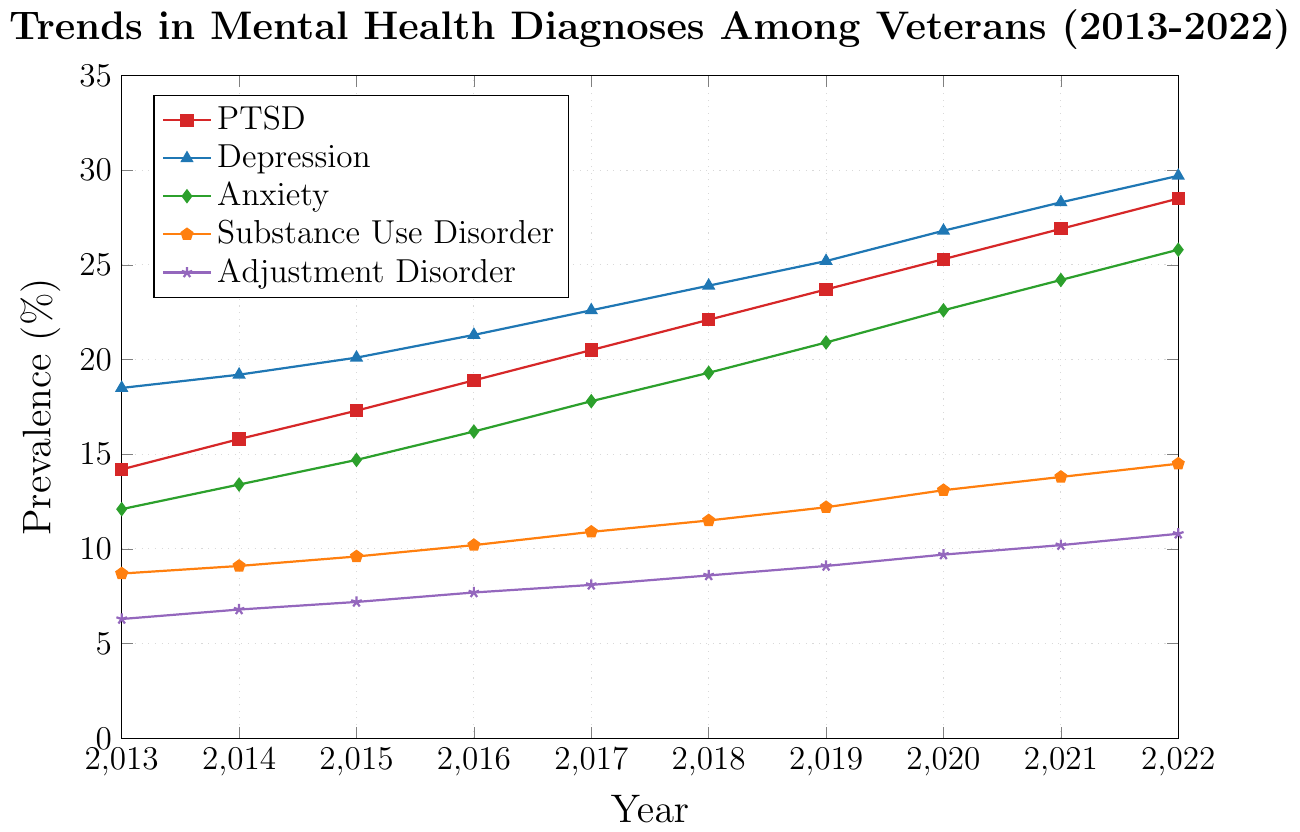What mental health disorder showed the highest prevalence rate in 2022? To determine the highest prevalence rate in 2022, we look at each mental health disorder's value for that year. The values are PTSD (28.5), Depression (29.7), Anxiety (25.8), Substance Use Disorder (14.5), Adjustment Disorder (10.8). Depression has the highest rate.
Answer: Depression Compare the rate of PTSD prevalence in 2013 and 2022. By what percentage did it increase? To calculate the percentage increase, take the value for 2022 (28.5) minus the value for 2013 (14.2), then divide by the 2013 value and multiply by 100: ((28.5 - 14.2) / 14.2) * 100. This results in about 100.7%.
Answer: 100.7% Which disorder showed the smallest increase in prevalence from 2013 to 2022? Examine the increase for each disorder by calculating the difference between their 2022 and 2013 values: PTSD (28.5 - 14.2 = 14.3), Depression (29.7 - 18.5 = 11.2), Anxiety (25.8 - 12.1 = 13.7), Substance Use Disorder (14.5 - 8.7 = 5.8), Adjustment Disorder (10.8 - 6.3 = 4.5). Adjustment Disorder had the smallest increase.
Answer: Adjustment Disorder How did the rate of Anxiety prevalence in 2020 compare to the rate of PTSD prevalence in 2016? To compare the values, look at Anxiety in 2020 (22.6) and PTSD in 2016 (18.9). Anxiety in 2020 was higher than PTSD in 2016.
Answer: Anxiety prevalence in 2020 was higher What was the average prevalence rate of PTSD over the decade shown? Calculate the average by summing up the prevalence rates over the years for PTSD and dividing by the number of years: (14.2 + 15.8 + 17.3 + 18.9 + 20.5 + 22.1 + 23.7 + 25.3 + 26.9 + 28.5) / 10 = 21.32.
Answer: 21.32 Between which consecutive years did Substance Use Disorder show the highest rate of increase? Calculate the year-to-year differences for Substance Use Disorder from 2013 to 2014, 0.4; from 2014 to 2015, 0.5; from 2015 to 2016, 0.6; from 2016 to 2017, 0.7; from 2017 to 2018, 0.6; from 2018 to 2019, 0.7; from 2019 to 2020, 0.9; from 2020 to 2021, 0.7; from 2021 to 2022, 0.7. The highest increase occurred between 2019 and 2020 (0.9).
Answer: 2019 and 2020 What's the trend of Adjustment Disorder prevalence from 2013 to 2022? Observe the data points for Adjustment Disorder from 2013 (6.3) to 2022 (10.8). The prevalence increased gradually each year, indicating a consistent upward trend.
Answer: Upward trend Which disorder had the second-highest prevalence in 2017 and what was its rate? Check the values for 2017: PTSD (20.5), Depression (22.6), Anxiety (17.8), Substance Use Disorder (10.9), and Adjustment Disorder (8.1). The second-highest in 2017 is PTSD with a rate of 20.5%.
Answer: PTSD, 20.5% What is the total increase in prevalence rate for Depression from 2013 to 2022? Calculate the difference between the 2022 value and the 2013 value for Depression: 29.7 - 18.5. This results in an increase of 11.2% over the decade.
Answer: 11.2% 